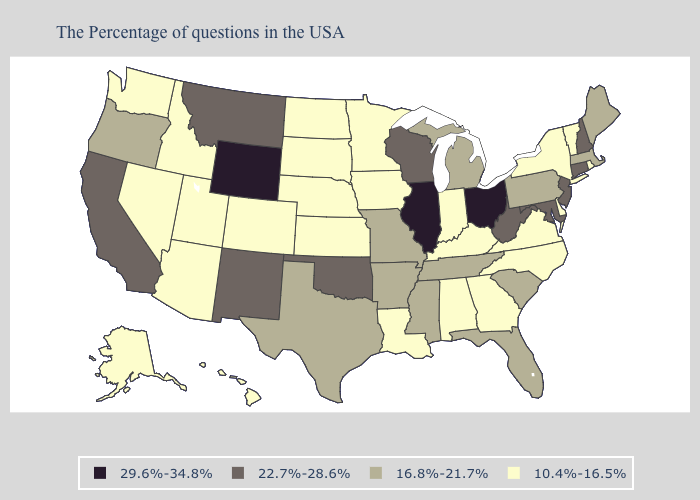Name the states that have a value in the range 10.4%-16.5%?
Give a very brief answer. Rhode Island, Vermont, New York, Delaware, Virginia, North Carolina, Georgia, Kentucky, Indiana, Alabama, Louisiana, Minnesota, Iowa, Kansas, Nebraska, South Dakota, North Dakota, Colorado, Utah, Arizona, Idaho, Nevada, Washington, Alaska, Hawaii. What is the highest value in states that border Tennessee?
Be succinct. 16.8%-21.7%. Name the states that have a value in the range 16.8%-21.7%?
Short answer required. Maine, Massachusetts, Pennsylvania, South Carolina, Florida, Michigan, Tennessee, Mississippi, Missouri, Arkansas, Texas, Oregon. What is the value of Texas?
Answer briefly. 16.8%-21.7%. Does West Virginia have the lowest value in the USA?
Answer briefly. No. Name the states that have a value in the range 22.7%-28.6%?
Concise answer only. New Hampshire, Connecticut, New Jersey, Maryland, West Virginia, Wisconsin, Oklahoma, New Mexico, Montana, California. What is the value of Illinois?
Answer briefly. 29.6%-34.8%. Name the states that have a value in the range 22.7%-28.6%?
Answer briefly. New Hampshire, Connecticut, New Jersey, Maryland, West Virginia, Wisconsin, Oklahoma, New Mexico, Montana, California. Does Minnesota have a higher value than Pennsylvania?
Short answer required. No. Among the states that border Colorado , does Kansas have the lowest value?
Give a very brief answer. Yes. What is the value of Utah?
Give a very brief answer. 10.4%-16.5%. What is the highest value in the USA?
Answer briefly. 29.6%-34.8%. Does Maine have the same value as Oregon?
Be succinct. Yes. Which states have the highest value in the USA?
Quick response, please. Ohio, Illinois, Wyoming. Does Louisiana have the highest value in the South?
Concise answer only. No. 